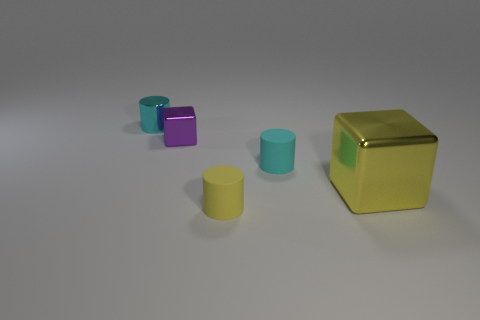Subtract all tiny cyan cylinders. How many cylinders are left? 1 Subtract all gray cubes. How many cyan cylinders are left? 2 Add 3 rubber objects. How many objects exist? 8 Subtract 1 cylinders. How many cylinders are left? 2 Subtract all yellow cylinders. How many cylinders are left? 2 Subtract 0 purple spheres. How many objects are left? 5 Subtract all cylinders. How many objects are left? 2 Subtract all green cylinders. Subtract all gray balls. How many cylinders are left? 3 Subtract all cyan objects. Subtract all rubber cylinders. How many objects are left? 1 Add 1 tiny cyan matte cylinders. How many tiny cyan matte cylinders are left? 2 